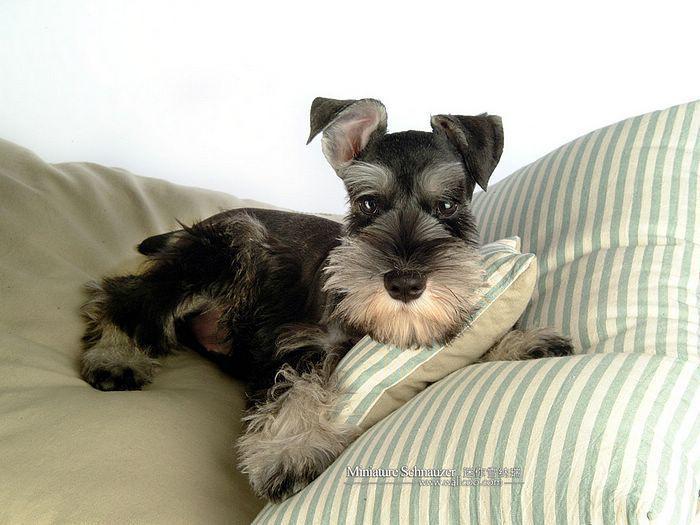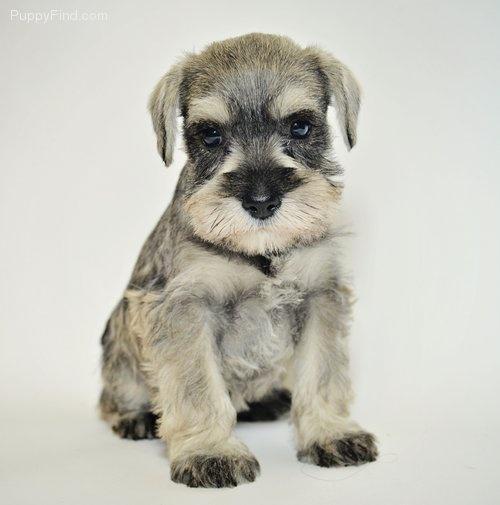The first image is the image on the left, the second image is the image on the right. Assess this claim about the two images: "An image shows a schnauzer posed on a wood plank floor.". Correct or not? Answer yes or no. No. The first image is the image on the left, the second image is the image on the right. Given the left and right images, does the statement "A dog is sitting on wood floor." hold true? Answer yes or no. No. 